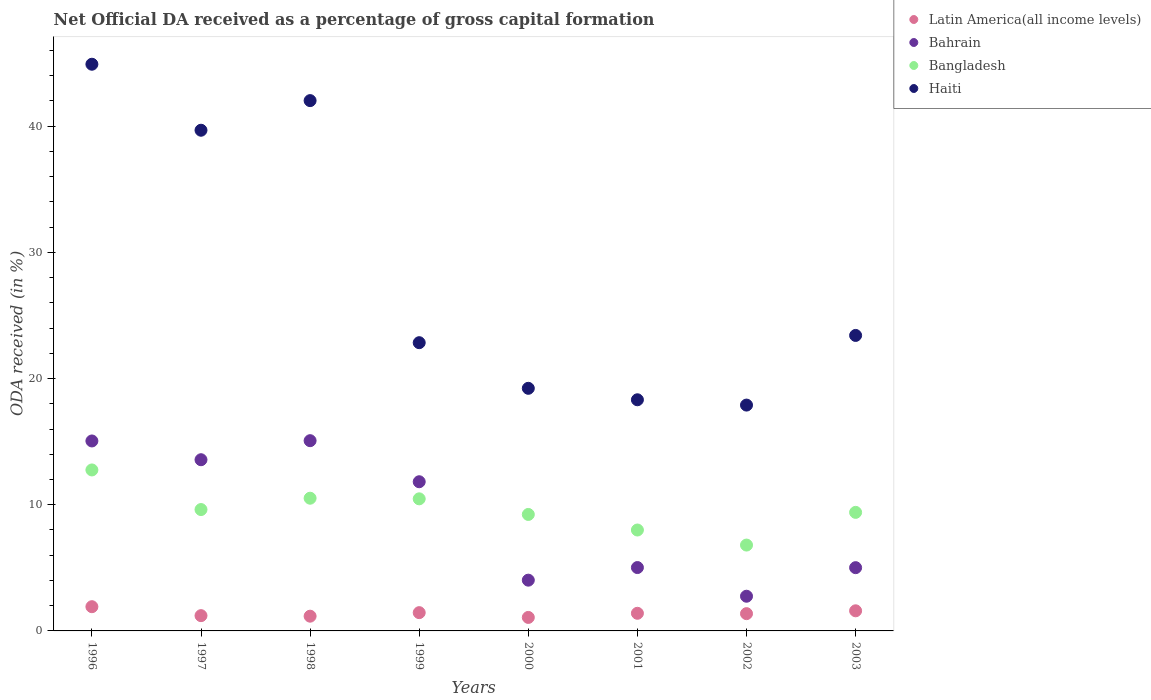How many different coloured dotlines are there?
Offer a terse response. 4. Is the number of dotlines equal to the number of legend labels?
Ensure brevity in your answer.  Yes. What is the net ODA received in Haiti in 2003?
Ensure brevity in your answer.  23.42. Across all years, what is the maximum net ODA received in Latin America(all income levels)?
Give a very brief answer. 1.92. Across all years, what is the minimum net ODA received in Latin America(all income levels)?
Give a very brief answer. 1.07. What is the total net ODA received in Bahrain in the graph?
Make the answer very short. 72.33. What is the difference between the net ODA received in Latin America(all income levels) in 1998 and that in 1999?
Your answer should be compact. -0.28. What is the difference between the net ODA received in Bahrain in 1999 and the net ODA received in Haiti in 1996?
Your answer should be compact. -33.09. What is the average net ODA received in Haiti per year?
Your answer should be very brief. 28.54. In the year 2002, what is the difference between the net ODA received in Bahrain and net ODA received in Latin America(all income levels)?
Offer a terse response. 1.38. What is the ratio of the net ODA received in Bahrain in 1996 to that in 2003?
Give a very brief answer. 3. Is the net ODA received in Bahrain in 2001 less than that in 2002?
Keep it short and to the point. No. What is the difference between the highest and the second highest net ODA received in Bangladesh?
Make the answer very short. 2.24. What is the difference between the highest and the lowest net ODA received in Latin America(all income levels)?
Your answer should be very brief. 0.85. Is the sum of the net ODA received in Latin America(all income levels) in 1996 and 2000 greater than the maximum net ODA received in Haiti across all years?
Keep it short and to the point. No. Is it the case that in every year, the sum of the net ODA received in Haiti and net ODA received in Latin America(all income levels)  is greater than the sum of net ODA received in Bahrain and net ODA received in Bangladesh?
Give a very brief answer. Yes. Does the net ODA received in Bangladesh monotonically increase over the years?
Give a very brief answer. No. Is the net ODA received in Bangladesh strictly less than the net ODA received in Latin America(all income levels) over the years?
Offer a very short reply. No. How many years are there in the graph?
Your answer should be very brief. 8. Are the values on the major ticks of Y-axis written in scientific E-notation?
Provide a short and direct response. No. Where does the legend appear in the graph?
Your response must be concise. Top right. How are the legend labels stacked?
Keep it short and to the point. Vertical. What is the title of the graph?
Your answer should be very brief. Net Official DA received as a percentage of gross capital formation. Does "Uruguay" appear as one of the legend labels in the graph?
Give a very brief answer. No. What is the label or title of the X-axis?
Keep it short and to the point. Years. What is the label or title of the Y-axis?
Your answer should be compact. ODA received (in %). What is the ODA received (in %) of Latin America(all income levels) in 1996?
Keep it short and to the point. 1.92. What is the ODA received (in %) in Bahrain in 1996?
Provide a short and direct response. 15.05. What is the ODA received (in %) of Bangladesh in 1996?
Your answer should be very brief. 12.76. What is the ODA received (in %) of Haiti in 1996?
Your answer should be compact. 44.91. What is the ODA received (in %) in Latin America(all income levels) in 1997?
Offer a very short reply. 1.21. What is the ODA received (in %) of Bahrain in 1997?
Keep it short and to the point. 13.57. What is the ODA received (in %) in Bangladesh in 1997?
Give a very brief answer. 9.62. What is the ODA received (in %) of Haiti in 1997?
Provide a succinct answer. 39.68. What is the ODA received (in %) of Latin America(all income levels) in 1998?
Keep it short and to the point. 1.17. What is the ODA received (in %) of Bahrain in 1998?
Ensure brevity in your answer.  15.08. What is the ODA received (in %) of Bangladesh in 1998?
Keep it short and to the point. 10.52. What is the ODA received (in %) in Haiti in 1998?
Ensure brevity in your answer.  42.03. What is the ODA received (in %) in Latin America(all income levels) in 1999?
Give a very brief answer. 1.45. What is the ODA received (in %) in Bahrain in 1999?
Provide a succinct answer. 11.82. What is the ODA received (in %) of Bangladesh in 1999?
Provide a succinct answer. 10.47. What is the ODA received (in %) in Haiti in 1999?
Your answer should be very brief. 22.84. What is the ODA received (in %) of Latin America(all income levels) in 2000?
Your response must be concise. 1.07. What is the ODA received (in %) of Bahrain in 2000?
Your answer should be compact. 4.02. What is the ODA received (in %) in Bangladesh in 2000?
Your response must be concise. 9.23. What is the ODA received (in %) of Haiti in 2000?
Make the answer very short. 19.23. What is the ODA received (in %) in Latin America(all income levels) in 2001?
Provide a short and direct response. 1.4. What is the ODA received (in %) in Bahrain in 2001?
Your response must be concise. 5.02. What is the ODA received (in %) of Bangladesh in 2001?
Provide a succinct answer. 8. What is the ODA received (in %) in Haiti in 2001?
Offer a terse response. 18.32. What is the ODA received (in %) of Latin America(all income levels) in 2002?
Offer a very short reply. 1.37. What is the ODA received (in %) of Bahrain in 2002?
Offer a very short reply. 2.75. What is the ODA received (in %) in Bangladesh in 2002?
Provide a succinct answer. 6.8. What is the ODA received (in %) of Haiti in 2002?
Offer a very short reply. 17.9. What is the ODA received (in %) in Latin America(all income levels) in 2003?
Make the answer very short. 1.59. What is the ODA received (in %) of Bahrain in 2003?
Your answer should be very brief. 5.01. What is the ODA received (in %) of Bangladesh in 2003?
Make the answer very short. 9.4. What is the ODA received (in %) of Haiti in 2003?
Provide a succinct answer. 23.42. Across all years, what is the maximum ODA received (in %) of Latin America(all income levels)?
Keep it short and to the point. 1.92. Across all years, what is the maximum ODA received (in %) of Bahrain?
Give a very brief answer. 15.08. Across all years, what is the maximum ODA received (in %) in Bangladesh?
Ensure brevity in your answer.  12.76. Across all years, what is the maximum ODA received (in %) in Haiti?
Keep it short and to the point. 44.91. Across all years, what is the minimum ODA received (in %) of Latin America(all income levels)?
Give a very brief answer. 1.07. Across all years, what is the minimum ODA received (in %) in Bahrain?
Give a very brief answer. 2.75. Across all years, what is the minimum ODA received (in %) of Bangladesh?
Your answer should be very brief. 6.8. Across all years, what is the minimum ODA received (in %) of Haiti?
Ensure brevity in your answer.  17.9. What is the total ODA received (in %) of Latin America(all income levels) in the graph?
Give a very brief answer. 11.18. What is the total ODA received (in %) in Bahrain in the graph?
Ensure brevity in your answer.  72.33. What is the total ODA received (in %) of Bangladesh in the graph?
Your response must be concise. 76.79. What is the total ODA received (in %) in Haiti in the graph?
Give a very brief answer. 228.31. What is the difference between the ODA received (in %) in Latin America(all income levels) in 1996 and that in 1997?
Keep it short and to the point. 0.71. What is the difference between the ODA received (in %) of Bahrain in 1996 and that in 1997?
Your answer should be very brief. 1.49. What is the difference between the ODA received (in %) in Bangladesh in 1996 and that in 1997?
Make the answer very short. 3.14. What is the difference between the ODA received (in %) in Haiti in 1996 and that in 1997?
Your response must be concise. 5.23. What is the difference between the ODA received (in %) of Latin America(all income levels) in 1996 and that in 1998?
Make the answer very short. 0.75. What is the difference between the ODA received (in %) in Bahrain in 1996 and that in 1998?
Ensure brevity in your answer.  -0.02. What is the difference between the ODA received (in %) in Bangladesh in 1996 and that in 1998?
Make the answer very short. 2.24. What is the difference between the ODA received (in %) of Haiti in 1996 and that in 1998?
Keep it short and to the point. 2.88. What is the difference between the ODA received (in %) of Latin America(all income levels) in 1996 and that in 1999?
Provide a succinct answer. 0.47. What is the difference between the ODA received (in %) in Bahrain in 1996 and that in 1999?
Ensure brevity in your answer.  3.23. What is the difference between the ODA received (in %) of Bangladesh in 1996 and that in 1999?
Give a very brief answer. 2.29. What is the difference between the ODA received (in %) in Haiti in 1996 and that in 1999?
Provide a succinct answer. 22.07. What is the difference between the ODA received (in %) of Latin America(all income levels) in 1996 and that in 2000?
Give a very brief answer. 0.85. What is the difference between the ODA received (in %) of Bahrain in 1996 and that in 2000?
Ensure brevity in your answer.  11.03. What is the difference between the ODA received (in %) of Bangladesh in 1996 and that in 2000?
Provide a short and direct response. 3.53. What is the difference between the ODA received (in %) in Haiti in 1996 and that in 2000?
Make the answer very short. 25.68. What is the difference between the ODA received (in %) in Latin America(all income levels) in 1996 and that in 2001?
Ensure brevity in your answer.  0.52. What is the difference between the ODA received (in %) of Bahrain in 1996 and that in 2001?
Your answer should be very brief. 10.03. What is the difference between the ODA received (in %) in Bangladesh in 1996 and that in 2001?
Offer a terse response. 4.76. What is the difference between the ODA received (in %) in Haiti in 1996 and that in 2001?
Your answer should be very brief. 26.59. What is the difference between the ODA received (in %) in Latin America(all income levels) in 1996 and that in 2002?
Provide a succinct answer. 0.55. What is the difference between the ODA received (in %) of Bahrain in 1996 and that in 2002?
Keep it short and to the point. 12.3. What is the difference between the ODA received (in %) in Bangladesh in 1996 and that in 2002?
Offer a very short reply. 5.95. What is the difference between the ODA received (in %) of Haiti in 1996 and that in 2002?
Provide a succinct answer. 27.01. What is the difference between the ODA received (in %) in Latin America(all income levels) in 1996 and that in 2003?
Make the answer very short. 0.33. What is the difference between the ODA received (in %) in Bahrain in 1996 and that in 2003?
Offer a terse response. 10.04. What is the difference between the ODA received (in %) in Bangladesh in 1996 and that in 2003?
Make the answer very short. 3.36. What is the difference between the ODA received (in %) in Haiti in 1996 and that in 2003?
Keep it short and to the point. 21.49. What is the difference between the ODA received (in %) in Latin America(all income levels) in 1997 and that in 1998?
Give a very brief answer. 0.04. What is the difference between the ODA received (in %) in Bahrain in 1997 and that in 1998?
Provide a short and direct response. -1.51. What is the difference between the ODA received (in %) of Bangladesh in 1997 and that in 1998?
Provide a succinct answer. -0.9. What is the difference between the ODA received (in %) in Haiti in 1997 and that in 1998?
Offer a very short reply. -2.35. What is the difference between the ODA received (in %) in Latin America(all income levels) in 1997 and that in 1999?
Ensure brevity in your answer.  -0.24. What is the difference between the ODA received (in %) of Bahrain in 1997 and that in 1999?
Provide a succinct answer. 1.74. What is the difference between the ODA received (in %) of Bangladesh in 1997 and that in 1999?
Give a very brief answer. -0.85. What is the difference between the ODA received (in %) of Haiti in 1997 and that in 1999?
Provide a succinct answer. 16.84. What is the difference between the ODA received (in %) of Latin America(all income levels) in 1997 and that in 2000?
Your answer should be compact. 0.14. What is the difference between the ODA received (in %) in Bahrain in 1997 and that in 2000?
Ensure brevity in your answer.  9.54. What is the difference between the ODA received (in %) in Bangladesh in 1997 and that in 2000?
Offer a very short reply. 0.39. What is the difference between the ODA received (in %) of Haiti in 1997 and that in 2000?
Give a very brief answer. 20.45. What is the difference between the ODA received (in %) in Latin America(all income levels) in 1997 and that in 2001?
Give a very brief answer. -0.19. What is the difference between the ODA received (in %) in Bahrain in 1997 and that in 2001?
Your answer should be very brief. 8.55. What is the difference between the ODA received (in %) in Bangladesh in 1997 and that in 2001?
Provide a short and direct response. 1.62. What is the difference between the ODA received (in %) in Haiti in 1997 and that in 2001?
Your answer should be very brief. 21.36. What is the difference between the ODA received (in %) in Latin America(all income levels) in 1997 and that in 2002?
Give a very brief answer. -0.16. What is the difference between the ODA received (in %) of Bahrain in 1997 and that in 2002?
Provide a short and direct response. 10.82. What is the difference between the ODA received (in %) in Bangladesh in 1997 and that in 2002?
Provide a succinct answer. 2.82. What is the difference between the ODA received (in %) of Haiti in 1997 and that in 2002?
Your response must be concise. 21.78. What is the difference between the ODA received (in %) in Latin America(all income levels) in 1997 and that in 2003?
Your answer should be compact. -0.38. What is the difference between the ODA received (in %) in Bahrain in 1997 and that in 2003?
Make the answer very short. 8.55. What is the difference between the ODA received (in %) of Bangladesh in 1997 and that in 2003?
Your answer should be very brief. 0.22. What is the difference between the ODA received (in %) in Haiti in 1997 and that in 2003?
Offer a terse response. 16.26. What is the difference between the ODA received (in %) in Latin America(all income levels) in 1998 and that in 1999?
Ensure brevity in your answer.  -0.28. What is the difference between the ODA received (in %) in Bahrain in 1998 and that in 1999?
Make the answer very short. 3.25. What is the difference between the ODA received (in %) in Bangladesh in 1998 and that in 1999?
Make the answer very short. 0.05. What is the difference between the ODA received (in %) in Haiti in 1998 and that in 1999?
Provide a short and direct response. 19.18. What is the difference between the ODA received (in %) in Latin America(all income levels) in 1998 and that in 2000?
Your response must be concise. 0.1. What is the difference between the ODA received (in %) of Bahrain in 1998 and that in 2000?
Offer a very short reply. 11.05. What is the difference between the ODA received (in %) in Bangladesh in 1998 and that in 2000?
Provide a short and direct response. 1.29. What is the difference between the ODA received (in %) of Haiti in 1998 and that in 2000?
Provide a succinct answer. 22.8. What is the difference between the ODA received (in %) in Latin America(all income levels) in 1998 and that in 2001?
Provide a short and direct response. -0.23. What is the difference between the ODA received (in %) of Bahrain in 1998 and that in 2001?
Make the answer very short. 10.05. What is the difference between the ODA received (in %) of Bangladesh in 1998 and that in 2001?
Provide a succinct answer. 2.52. What is the difference between the ODA received (in %) in Haiti in 1998 and that in 2001?
Your response must be concise. 23.71. What is the difference between the ODA received (in %) of Latin America(all income levels) in 1998 and that in 2002?
Offer a terse response. -0.2. What is the difference between the ODA received (in %) in Bahrain in 1998 and that in 2002?
Make the answer very short. 12.33. What is the difference between the ODA received (in %) of Bangladesh in 1998 and that in 2002?
Offer a terse response. 3.71. What is the difference between the ODA received (in %) in Haiti in 1998 and that in 2002?
Offer a terse response. 24.13. What is the difference between the ODA received (in %) of Latin America(all income levels) in 1998 and that in 2003?
Your response must be concise. -0.43. What is the difference between the ODA received (in %) in Bahrain in 1998 and that in 2003?
Provide a succinct answer. 10.06. What is the difference between the ODA received (in %) of Bangladesh in 1998 and that in 2003?
Your response must be concise. 1.12. What is the difference between the ODA received (in %) in Haiti in 1998 and that in 2003?
Keep it short and to the point. 18.61. What is the difference between the ODA received (in %) of Latin America(all income levels) in 1999 and that in 2000?
Your response must be concise. 0.38. What is the difference between the ODA received (in %) in Bahrain in 1999 and that in 2000?
Your answer should be compact. 7.8. What is the difference between the ODA received (in %) of Bangladesh in 1999 and that in 2000?
Your answer should be compact. 1.24. What is the difference between the ODA received (in %) of Haiti in 1999 and that in 2000?
Provide a succinct answer. 3.62. What is the difference between the ODA received (in %) of Latin America(all income levels) in 1999 and that in 2001?
Offer a very short reply. 0.05. What is the difference between the ODA received (in %) of Bahrain in 1999 and that in 2001?
Provide a succinct answer. 6.8. What is the difference between the ODA received (in %) in Bangladesh in 1999 and that in 2001?
Your response must be concise. 2.47. What is the difference between the ODA received (in %) of Haiti in 1999 and that in 2001?
Your answer should be very brief. 4.52. What is the difference between the ODA received (in %) of Latin America(all income levels) in 1999 and that in 2002?
Your answer should be compact. 0.08. What is the difference between the ODA received (in %) in Bahrain in 1999 and that in 2002?
Ensure brevity in your answer.  9.07. What is the difference between the ODA received (in %) of Bangladesh in 1999 and that in 2002?
Your response must be concise. 3.66. What is the difference between the ODA received (in %) in Haiti in 1999 and that in 2002?
Ensure brevity in your answer.  4.95. What is the difference between the ODA received (in %) of Latin America(all income levels) in 1999 and that in 2003?
Provide a short and direct response. -0.15. What is the difference between the ODA received (in %) in Bahrain in 1999 and that in 2003?
Give a very brief answer. 6.81. What is the difference between the ODA received (in %) in Bangladesh in 1999 and that in 2003?
Offer a terse response. 1.07. What is the difference between the ODA received (in %) of Haiti in 1999 and that in 2003?
Provide a short and direct response. -0.57. What is the difference between the ODA received (in %) of Latin America(all income levels) in 2000 and that in 2001?
Your response must be concise. -0.33. What is the difference between the ODA received (in %) in Bahrain in 2000 and that in 2001?
Provide a short and direct response. -1. What is the difference between the ODA received (in %) in Bangladesh in 2000 and that in 2001?
Ensure brevity in your answer.  1.23. What is the difference between the ODA received (in %) of Haiti in 2000 and that in 2001?
Your response must be concise. 0.91. What is the difference between the ODA received (in %) in Latin America(all income levels) in 2000 and that in 2002?
Keep it short and to the point. -0.3. What is the difference between the ODA received (in %) of Bahrain in 2000 and that in 2002?
Make the answer very short. 1.27. What is the difference between the ODA received (in %) of Bangladesh in 2000 and that in 2002?
Provide a succinct answer. 2.43. What is the difference between the ODA received (in %) in Haiti in 2000 and that in 2002?
Your answer should be compact. 1.33. What is the difference between the ODA received (in %) of Latin America(all income levels) in 2000 and that in 2003?
Your response must be concise. -0.52. What is the difference between the ODA received (in %) of Bahrain in 2000 and that in 2003?
Provide a succinct answer. -0.99. What is the difference between the ODA received (in %) in Bangladesh in 2000 and that in 2003?
Provide a short and direct response. -0.17. What is the difference between the ODA received (in %) in Haiti in 2000 and that in 2003?
Ensure brevity in your answer.  -4.19. What is the difference between the ODA received (in %) in Latin America(all income levels) in 2001 and that in 2002?
Your answer should be very brief. 0.03. What is the difference between the ODA received (in %) of Bahrain in 2001 and that in 2002?
Offer a terse response. 2.27. What is the difference between the ODA received (in %) in Bangladesh in 2001 and that in 2002?
Offer a terse response. 1.19. What is the difference between the ODA received (in %) in Haiti in 2001 and that in 2002?
Provide a short and direct response. 0.42. What is the difference between the ODA received (in %) of Latin America(all income levels) in 2001 and that in 2003?
Offer a very short reply. -0.2. What is the difference between the ODA received (in %) of Bahrain in 2001 and that in 2003?
Provide a short and direct response. 0.01. What is the difference between the ODA received (in %) in Bangladesh in 2001 and that in 2003?
Your answer should be compact. -1.4. What is the difference between the ODA received (in %) in Haiti in 2001 and that in 2003?
Offer a very short reply. -5.1. What is the difference between the ODA received (in %) in Latin America(all income levels) in 2002 and that in 2003?
Give a very brief answer. -0.22. What is the difference between the ODA received (in %) in Bahrain in 2002 and that in 2003?
Keep it short and to the point. -2.26. What is the difference between the ODA received (in %) in Bangladesh in 2002 and that in 2003?
Your answer should be compact. -2.59. What is the difference between the ODA received (in %) in Haiti in 2002 and that in 2003?
Make the answer very short. -5.52. What is the difference between the ODA received (in %) in Latin America(all income levels) in 1996 and the ODA received (in %) in Bahrain in 1997?
Provide a succinct answer. -11.65. What is the difference between the ODA received (in %) in Latin America(all income levels) in 1996 and the ODA received (in %) in Bangladesh in 1997?
Give a very brief answer. -7.7. What is the difference between the ODA received (in %) in Latin America(all income levels) in 1996 and the ODA received (in %) in Haiti in 1997?
Provide a succinct answer. -37.76. What is the difference between the ODA received (in %) in Bahrain in 1996 and the ODA received (in %) in Bangladesh in 1997?
Make the answer very short. 5.44. What is the difference between the ODA received (in %) of Bahrain in 1996 and the ODA received (in %) of Haiti in 1997?
Provide a short and direct response. -24.62. What is the difference between the ODA received (in %) in Bangladesh in 1996 and the ODA received (in %) in Haiti in 1997?
Provide a short and direct response. -26.92. What is the difference between the ODA received (in %) of Latin America(all income levels) in 1996 and the ODA received (in %) of Bahrain in 1998?
Give a very brief answer. -13.16. What is the difference between the ODA received (in %) in Latin America(all income levels) in 1996 and the ODA received (in %) in Bangladesh in 1998?
Give a very brief answer. -8.6. What is the difference between the ODA received (in %) in Latin America(all income levels) in 1996 and the ODA received (in %) in Haiti in 1998?
Offer a very short reply. -40.11. What is the difference between the ODA received (in %) of Bahrain in 1996 and the ODA received (in %) of Bangladesh in 1998?
Your response must be concise. 4.54. What is the difference between the ODA received (in %) of Bahrain in 1996 and the ODA received (in %) of Haiti in 1998?
Offer a very short reply. -26.97. What is the difference between the ODA received (in %) in Bangladesh in 1996 and the ODA received (in %) in Haiti in 1998?
Offer a very short reply. -29.27. What is the difference between the ODA received (in %) in Latin America(all income levels) in 1996 and the ODA received (in %) in Bahrain in 1999?
Keep it short and to the point. -9.9. What is the difference between the ODA received (in %) in Latin America(all income levels) in 1996 and the ODA received (in %) in Bangladesh in 1999?
Provide a short and direct response. -8.55. What is the difference between the ODA received (in %) of Latin America(all income levels) in 1996 and the ODA received (in %) of Haiti in 1999?
Give a very brief answer. -20.92. What is the difference between the ODA received (in %) of Bahrain in 1996 and the ODA received (in %) of Bangladesh in 1999?
Make the answer very short. 4.59. What is the difference between the ODA received (in %) of Bahrain in 1996 and the ODA received (in %) of Haiti in 1999?
Provide a succinct answer. -7.79. What is the difference between the ODA received (in %) of Bangladesh in 1996 and the ODA received (in %) of Haiti in 1999?
Keep it short and to the point. -10.09. What is the difference between the ODA received (in %) in Latin America(all income levels) in 1996 and the ODA received (in %) in Bahrain in 2000?
Your answer should be very brief. -2.1. What is the difference between the ODA received (in %) in Latin America(all income levels) in 1996 and the ODA received (in %) in Bangladesh in 2000?
Provide a succinct answer. -7.31. What is the difference between the ODA received (in %) in Latin America(all income levels) in 1996 and the ODA received (in %) in Haiti in 2000?
Ensure brevity in your answer.  -17.31. What is the difference between the ODA received (in %) in Bahrain in 1996 and the ODA received (in %) in Bangladesh in 2000?
Your answer should be very brief. 5.82. What is the difference between the ODA received (in %) of Bahrain in 1996 and the ODA received (in %) of Haiti in 2000?
Ensure brevity in your answer.  -4.17. What is the difference between the ODA received (in %) of Bangladesh in 1996 and the ODA received (in %) of Haiti in 2000?
Ensure brevity in your answer.  -6.47. What is the difference between the ODA received (in %) in Latin America(all income levels) in 1996 and the ODA received (in %) in Bahrain in 2001?
Your response must be concise. -3.1. What is the difference between the ODA received (in %) of Latin America(all income levels) in 1996 and the ODA received (in %) of Bangladesh in 2001?
Your answer should be very brief. -6.08. What is the difference between the ODA received (in %) in Latin America(all income levels) in 1996 and the ODA received (in %) in Haiti in 2001?
Make the answer very short. -16.4. What is the difference between the ODA received (in %) in Bahrain in 1996 and the ODA received (in %) in Bangladesh in 2001?
Provide a succinct answer. 7.06. What is the difference between the ODA received (in %) in Bahrain in 1996 and the ODA received (in %) in Haiti in 2001?
Offer a very short reply. -3.26. What is the difference between the ODA received (in %) in Bangladesh in 1996 and the ODA received (in %) in Haiti in 2001?
Provide a short and direct response. -5.56. What is the difference between the ODA received (in %) in Latin America(all income levels) in 1996 and the ODA received (in %) in Bahrain in 2002?
Your response must be concise. -0.83. What is the difference between the ODA received (in %) in Latin America(all income levels) in 1996 and the ODA received (in %) in Bangladesh in 2002?
Offer a very short reply. -4.88. What is the difference between the ODA received (in %) in Latin America(all income levels) in 1996 and the ODA received (in %) in Haiti in 2002?
Provide a succinct answer. -15.98. What is the difference between the ODA received (in %) in Bahrain in 1996 and the ODA received (in %) in Bangladesh in 2002?
Your answer should be very brief. 8.25. What is the difference between the ODA received (in %) of Bahrain in 1996 and the ODA received (in %) of Haiti in 2002?
Your answer should be compact. -2.84. What is the difference between the ODA received (in %) of Bangladesh in 1996 and the ODA received (in %) of Haiti in 2002?
Your answer should be compact. -5.14. What is the difference between the ODA received (in %) in Latin America(all income levels) in 1996 and the ODA received (in %) in Bahrain in 2003?
Provide a succinct answer. -3.09. What is the difference between the ODA received (in %) in Latin America(all income levels) in 1996 and the ODA received (in %) in Bangladesh in 2003?
Your answer should be compact. -7.48. What is the difference between the ODA received (in %) of Latin America(all income levels) in 1996 and the ODA received (in %) of Haiti in 2003?
Provide a succinct answer. -21.5. What is the difference between the ODA received (in %) in Bahrain in 1996 and the ODA received (in %) in Bangladesh in 2003?
Your answer should be compact. 5.66. What is the difference between the ODA received (in %) of Bahrain in 1996 and the ODA received (in %) of Haiti in 2003?
Offer a terse response. -8.36. What is the difference between the ODA received (in %) of Bangladesh in 1996 and the ODA received (in %) of Haiti in 2003?
Provide a short and direct response. -10.66. What is the difference between the ODA received (in %) of Latin America(all income levels) in 1997 and the ODA received (in %) of Bahrain in 1998?
Provide a succinct answer. -13.87. What is the difference between the ODA received (in %) of Latin America(all income levels) in 1997 and the ODA received (in %) of Bangladesh in 1998?
Your answer should be very brief. -9.31. What is the difference between the ODA received (in %) of Latin America(all income levels) in 1997 and the ODA received (in %) of Haiti in 1998?
Offer a terse response. -40.82. What is the difference between the ODA received (in %) of Bahrain in 1997 and the ODA received (in %) of Bangladesh in 1998?
Give a very brief answer. 3.05. What is the difference between the ODA received (in %) of Bahrain in 1997 and the ODA received (in %) of Haiti in 1998?
Your answer should be compact. -28.46. What is the difference between the ODA received (in %) of Bangladesh in 1997 and the ODA received (in %) of Haiti in 1998?
Your answer should be compact. -32.41. What is the difference between the ODA received (in %) of Latin America(all income levels) in 1997 and the ODA received (in %) of Bahrain in 1999?
Provide a short and direct response. -10.61. What is the difference between the ODA received (in %) of Latin America(all income levels) in 1997 and the ODA received (in %) of Bangladesh in 1999?
Keep it short and to the point. -9.26. What is the difference between the ODA received (in %) of Latin America(all income levels) in 1997 and the ODA received (in %) of Haiti in 1999?
Ensure brevity in your answer.  -21.63. What is the difference between the ODA received (in %) in Bahrain in 1997 and the ODA received (in %) in Bangladesh in 1999?
Your answer should be very brief. 3.1. What is the difference between the ODA received (in %) in Bahrain in 1997 and the ODA received (in %) in Haiti in 1999?
Your answer should be very brief. -9.28. What is the difference between the ODA received (in %) in Bangladesh in 1997 and the ODA received (in %) in Haiti in 1999?
Give a very brief answer. -13.22. What is the difference between the ODA received (in %) in Latin America(all income levels) in 1997 and the ODA received (in %) in Bahrain in 2000?
Make the answer very short. -2.81. What is the difference between the ODA received (in %) in Latin America(all income levels) in 1997 and the ODA received (in %) in Bangladesh in 2000?
Your answer should be compact. -8.02. What is the difference between the ODA received (in %) of Latin America(all income levels) in 1997 and the ODA received (in %) of Haiti in 2000?
Give a very brief answer. -18.02. What is the difference between the ODA received (in %) in Bahrain in 1997 and the ODA received (in %) in Bangladesh in 2000?
Offer a very short reply. 4.34. What is the difference between the ODA received (in %) in Bahrain in 1997 and the ODA received (in %) in Haiti in 2000?
Provide a succinct answer. -5.66. What is the difference between the ODA received (in %) of Bangladesh in 1997 and the ODA received (in %) of Haiti in 2000?
Provide a short and direct response. -9.61. What is the difference between the ODA received (in %) of Latin America(all income levels) in 1997 and the ODA received (in %) of Bahrain in 2001?
Your answer should be compact. -3.81. What is the difference between the ODA received (in %) in Latin America(all income levels) in 1997 and the ODA received (in %) in Bangladesh in 2001?
Ensure brevity in your answer.  -6.79. What is the difference between the ODA received (in %) of Latin America(all income levels) in 1997 and the ODA received (in %) of Haiti in 2001?
Make the answer very short. -17.11. What is the difference between the ODA received (in %) of Bahrain in 1997 and the ODA received (in %) of Bangladesh in 2001?
Offer a very short reply. 5.57. What is the difference between the ODA received (in %) in Bahrain in 1997 and the ODA received (in %) in Haiti in 2001?
Offer a very short reply. -4.75. What is the difference between the ODA received (in %) in Bangladesh in 1997 and the ODA received (in %) in Haiti in 2001?
Your answer should be compact. -8.7. What is the difference between the ODA received (in %) in Latin America(all income levels) in 1997 and the ODA received (in %) in Bahrain in 2002?
Give a very brief answer. -1.54. What is the difference between the ODA received (in %) of Latin America(all income levels) in 1997 and the ODA received (in %) of Bangladesh in 2002?
Make the answer very short. -5.59. What is the difference between the ODA received (in %) in Latin America(all income levels) in 1997 and the ODA received (in %) in Haiti in 2002?
Your answer should be very brief. -16.69. What is the difference between the ODA received (in %) in Bahrain in 1997 and the ODA received (in %) in Bangladesh in 2002?
Keep it short and to the point. 6.76. What is the difference between the ODA received (in %) of Bahrain in 1997 and the ODA received (in %) of Haiti in 2002?
Make the answer very short. -4.33. What is the difference between the ODA received (in %) of Bangladesh in 1997 and the ODA received (in %) of Haiti in 2002?
Your response must be concise. -8.28. What is the difference between the ODA received (in %) of Latin America(all income levels) in 1997 and the ODA received (in %) of Bahrain in 2003?
Give a very brief answer. -3.8. What is the difference between the ODA received (in %) in Latin America(all income levels) in 1997 and the ODA received (in %) in Bangladesh in 2003?
Ensure brevity in your answer.  -8.19. What is the difference between the ODA received (in %) of Latin America(all income levels) in 1997 and the ODA received (in %) of Haiti in 2003?
Offer a terse response. -22.21. What is the difference between the ODA received (in %) in Bahrain in 1997 and the ODA received (in %) in Bangladesh in 2003?
Your answer should be very brief. 4.17. What is the difference between the ODA received (in %) in Bahrain in 1997 and the ODA received (in %) in Haiti in 2003?
Provide a short and direct response. -9.85. What is the difference between the ODA received (in %) of Bangladesh in 1997 and the ODA received (in %) of Haiti in 2003?
Your answer should be very brief. -13.8. What is the difference between the ODA received (in %) of Latin America(all income levels) in 1998 and the ODA received (in %) of Bahrain in 1999?
Your response must be concise. -10.65. What is the difference between the ODA received (in %) of Latin America(all income levels) in 1998 and the ODA received (in %) of Bangladesh in 1999?
Your answer should be compact. -9.3. What is the difference between the ODA received (in %) in Latin America(all income levels) in 1998 and the ODA received (in %) in Haiti in 1999?
Provide a succinct answer. -21.67. What is the difference between the ODA received (in %) in Bahrain in 1998 and the ODA received (in %) in Bangladesh in 1999?
Give a very brief answer. 4.61. What is the difference between the ODA received (in %) of Bahrain in 1998 and the ODA received (in %) of Haiti in 1999?
Offer a very short reply. -7.77. What is the difference between the ODA received (in %) of Bangladesh in 1998 and the ODA received (in %) of Haiti in 1999?
Provide a short and direct response. -12.33. What is the difference between the ODA received (in %) in Latin America(all income levels) in 1998 and the ODA received (in %) in Bahrain in 2000?
Provide a short and direct response. -2.85. What is the difference between the ODA received (in %) in Latin America(all income levels) in 1998 and the ODA received (in %) in Bangladesh in 2000?
Provide a short and direct response. -8.06. What is the difference between the ODA received (in %) in Latin America(all income levels) in 1998 and the ODA received (in %) in Haiti in 2000?
Keep it short and to the point. -18.06. What is the difference between the ODA received (in %) in Bahrain in 1998 and the ODA received (in %) in Bangladesh in 2000?
Offer a very short reply. 5.85. What is the difference between the ODA received (in %) of Bahrain in 1998 and the ODA received (in %) of Haiti in 2000?
Provide a succinct answer. -4.15. What is the difference between the ODA received (in %) in Bangladesh in 1998 and the ODA received (in %) in Haiti in 2000?
Offer a terse response. -8.71. What is the difference between the ODA received (in %) in Latin America(all income levels) in 1998 and the ODA received (in %) in Bahrain in 2001?
Provide a succinct answer. -3.85. What is the difference between the ODA received (in %) in Latin America(all income levels) in 1998 and the ODA received (in %) in Bangladesh in 2001?
Offer a very short reply. -6.83. What is the difference between the ODA received (in %) of Latin America(all income levels) in 1998 and the ODA received (in %) of Haiti in 2001?
Offer a terse response. -17.15. What is the difference between the ODA received (in %) in Bahrain in 1998 and the ODA received (in %) in Bangladesh in 2001?
Offer a very short reply. 7.08. What is the difference between the ODA received (in %) of Bahrain in 1998 and the ODA received (in %) of Haiti in 2001?
Ensure brevity in your answer.  -3.24. What is the difference between the ODA received (in %) of Bangladesh in 1998 and the ODA received (in %) of Haiti in 2001?
Keep it short and to the point. -7.8. What is the difference between the ODA received (in %) of Latin America(all income levels) in 1998 and the ODA received (in %) of Bahrain in 2002?
Provide a short and direct response. -1.58. What is the difference between the ODA received (in %) of Latin America(all income levels) in 1998 and the ODA received (in %) of Bangladesh in 2002?
Give a very brief answer. -5.64. What is the difference between the ODA received (in %) of Latin America(all income levels) in 1998 and the ODA received (in %) of Haiti in 2002?
Offer a very short reply. -16.73. What is the difference between the ODA received (in %) in Bahrain in 1998 and the ODA received (in %) in Bangladesh in 2002?
Provide a short and direct response. 8.27. What is the difference between the ODA received (in %) in Bahrain in 1998 and the ODA received (in %) in Haiti in 2002?
Your answer should be very brief. -2.82. What is the difference between the ODA received (in %) in Bangladesh in 1998 and the ODA received (in %) in Haiti in 2002?
Provide a short and direct response. -7.38. What is the difference between the ODA received (in %) in Latin America(all income levels) in 1998 and the ODA received (in %) in Bahrain in 2003?
Offer a very short reply. -3.84. What is the difference between the ODA received (in %) of Latin America(all income levels) in 1998 and the ODA received (in %) of Bangladesh in 2003?
Your answer should be compact. -8.23. What is the difference between the ODA received (in %) in Latin America(all income levels) in 1998 and the ODA received (in %) in Haiti in 2003?
Your response must be concise. -22.25. What is the difference between the ODA received (in %) of Bahrain in 1998 and the ODA received (in %) of Bangladesh in 2003?
Give a very brief answer. 5.68. What is the difference between the ODA received (in %) of Bahrain in 1998 and the ODA received (in %) of Haiti in 2003?
Your answer should be compact. -8.34. What is the difference between the ODA received (in %) of Bangladesh in 1998 and the ODA received (in %) of Haiti in 2003?
Make the answer very short. -12.9. What is the difference between the ODA received (in %) of Latin America(all income levels) in 1999 and the ODA received (in %) of Bahrain in 2000?
Provide a succinct answer. -2.57. What is the difference between the ODA received (in %) of Latin America(all income levels) in 1999 and the ODA received (in %) of Bangladesh in 2000?
Keep it short and to the point. -7.78. What is the difference between the ODA received (in %) in Latin America(all income levels) in 1999 and the ODA received (in %) in Haiti in 2000?
Offer a very short reply. -17.78. What is the difference between the ODA received (in %) in Bahrain in 1999 and the ODA received (in %) in Bangladesh in 2000?
Your response must be concise. 2.59. What is the difference between the ODA received (in %) in Bahrain in 1999 and the ODA received (in %) in Haiti in 2000?
Your answer should be compact. -7.4. What is the difference between the ODA received (in %) of Bangladesh in 1999 and the ODA received (in %) of Haiti in 2000?
Offer a terse response. -8.76. What is the difference between the ODA received (in %) in Latin America(all income levels) in 1999 and the ODA received (in %) in Bahrain in 2001?
Your response must be concise. -3.57. What is the difference between the ODA received (in %) of Latin America(all income levels) in 1999 and the ODA received (in %) of Bangladesh in 2001?
Make the answer very short. -6.55. What is the difference between the ODA received (in %) of Latin America(all income levels) in 1999 and the ODA received (in %) of Haiti in 2001?
Make the answer very short. -16.87. What is the difference between the ODA received (in %) in Bahrain in 1999 and the ODA received (in %) in Bangladesh in 2001?
Keep it short and to the point. 3.83. What is the difference between the ODA received (in %) in Bahrain in 1999 and the ODA received (in %) in Haiti in 2001?
Provide a succinct answer. -6.5. What is the difference between the ODA received (in %) in Bangladesh in 1999 and the ODA received (in %) in Haiti in 2001?
Your answer should be very brief. -7.85. What is the difference between the ODA received (in %) of Latin America(all income levels) in 1999 and the ODA received (in %) of Bahrain in 2002?
Offer a terse response. -1.3. What is the difference between the ODA received (in %) in Latin America(all income levels) in 1999 and the ODA received (in %) in Bangladesh in 2002?
Offer a terse response. -5.35. What is the difference between the ODA received (in %) in Latin America(all income levels) in 1999 and the ODA received (in %) in Haiti in 2002?
Offer a very short reply. -16.45. What is the difference between the ODA received (in %) in Bahrain in 1999 and the ODA received (in %) in Bangladesh in 2002?
Your answer should be compact. 5.02. What is the difference between the ODA received (in %) in Bahrain in 1999 and the ODA received (in %) in Haiti in 2002?
Ensure brevity in your answer.  -6.07. What is the difference between the ODA received (in %) of Bangladesh in 1999 and the ODA received (in %) of Haiti in 2002?
Offer a terse response. -7.43. What is the difference between the ODA received (in %) of Latin America(all income levels) in 1999 and the ODA received (in %) of Bahrain in 2003?
Ensure brevity in your answer.  -3.56. What is the difference between the ODA received (in %) in Latin America(all income levels) in 1999 and the ODA received (in %) in Bangladesh in 2003?
Give a very brief answer. -7.95. What is the difference between the ODA received (in %) of Latin America(all income levels) in 1999 and the ODA received (in %) of Haiti in 2003?
Provide a succinct answer. -21.97. What is the difference between the ODA received (in %) of Bahrain in 1999 and the ODA received (in %) of Bangladesh in 2003?
Ensure brevity in your answer.  2.43. What is the difference between the ODA received (in %) of Bahrain in 1999 and the ODA received (in %) of Haiti in 2003?
Offer a terse response. -11.59. What is the difference between the ODA received (in %) in Bangladesh in 1999 and the ODA received (in %) in Haiti in 2003?
Your answer should be very brief. -12.95. What is the difference between the ODA received (in %) of Latin America(all income levels) in 2000 and the ODA received (in %) of Bahrain in 2001?
Your answer should be compact. -3.95. What is the difference between the ODA received (in %) of Latin America(all income levels) in 2000 and the ODA received (in %) of Bangladesh in 2001?
Your answer should be very brief. -6.93. What is the difference between the ODA received (in %) of Latin America(all income levels) in 2000 and the ODA received (in %) of Haiti in 2001?
Keep it short and to the point. -17.25. What is the difference between the ODA received (in %) in Bahrain in 2000 and the ODA received (in %) in Bangladesh in 2001?
Offer a terse response. -3.97. What is the difference between the ODA received (in %) of Bahrain in 2000 and the ODA received (in %) of Haiti in 2001?
Ensure brevity in your answer.  -14.29. What is the difference between the ODA received (in %) in Bangladesh in 2000 and the ODA received (in %) in Haiti in 2001?
Keep it short and to the point. -9.09. What is the difference between the ODA received (in %) in Latin America(all income levels) in 2000 and the ODA received (in %) in Bahrain in 2002?
Provide a succinct answer. -1.68. What is the difference between the ODA received (in %) of Latin America(all income levels) in 2000 and the ODA received (in %) of Bangladesh in 2002?
Give a very brief answer. -5.73. What is the difference between the ODA received (in %) in Latin America(all income levels) in 2000 and the ODA received (in %) in Haiti in 2002?
Keep it short and to the point. -16.83. What is the difference between the ODA received (in %) in Bahrain in 2000 and the ODA received (in %) in Bangladesh in 2002?
Your answer should be compact. -2.78. What is the difference between the ODA received (in %) of Bahrain in 2000 and the ODA received (in %) of Haiti in 2002?
Ensure brevity in your answer.  -13.87. What is the difference between the ODA received (in %) in Bangladesh in 2000 and the ODA received (in %) in Haiti in 2002?
Your answer should be very brief. -8.67. What is the difference between the ODA received (in %) in Latin America(all income levels) in 2000 and the ODA received (in %) in Bahrain in 2003?
Provide a short and direct response. -3.94. What is the difference between the ODA received (in %) of Latin America(all income levels) in 2000 and the ODA received (in %) of Bangladesh in 2003?
Keep it short and to the point. -8.33. What is the difference between the ODA received (in %) in Latin America(all income levels) in 2000 and the ODA received (in %) in Haiti in 2003?
Give a very brief answer. -22.35. What is the difference between the ODA received (in %) of Bahrain in 2000 and the ODA received (in %) of Bangladesh in 2003?
Provide a short and direct response. -5.37. What is the difference between the ODA received (in %) in Bahrain in 2000 and the ODA received (in %) in Haiti in 2003?
Ensure brevity in your answer.  -19.39. What is the difference between the ODA received (in %) of Bangladesh in 2000 and the ODA received (in %) of Haiti in 2003?
Give a very brief answer. -14.19. What is the difference between the ODA received (in %) of Latin America(all income levels) in 2001 and the ODA received (in %) of Bahrain in 2002?
Keep it short and to the point. -1.35. What is the difference between the ODA received (in %) in Latin America(all income levels) in 2001 and the ODA received (in %) in Bangladesh in 2002?
Ensure brevity in your answer.  -5.41. What is the difference between the ODA received (in %) of Latin America(all income levels) in 2001 and the ODA received (in %) of Haiti in 2002?
Your response must be concise. -16.5. What is the difference between the ODA received (in %) of Bahrain in 2001 and the ODA received (in %) of Bangladesh in 2002?
Offer a terse response. -1.78. What is the difference between the ODA received (in %) of Bahrain in 2001 and the ODA received (in %) of Haiti in 2002?
Make the answer very short. -12.88. What is the difference between the ODA received (in %) of Bangladesh in 2001 and the ODA received (in %) of Haiti in 2002?
Provide a succinct answer. -9.9. What is the difference between the ODA received (in %) of Latin America(all income levels) in 2001 and the ODA received (in %) of Bahrain in 2003?
Offer a terse response. -3.62. What is the difference between the ODA received (in %) of Latin America(all income levels) in 2001 and the ODA received (in %) of Bangladesh in 2003?
Offer a very short reply. -8. What is the difference between the ODA received (in %) of Latin America(all income levels) in 2001 and the ODA received (in %) of Haiti in 2003?
Your response must be concise. -22.02. What is the difference between the ODA received (in %) in Bahrain in 2001 and the ODA received (in %) in Bangladesh in 2003?
Offer a very short reply. -4.37. What is the difference between the ODA received (in %) of Bahrain in 2001 and the ODA received (in %) of Haiti in 2003?
Offer a terse response. -18.4. What is the difference between the ODA received (in %) of Bangladesh in 2001 and the ODA received (in %) of Haiti in 2003?
Your answer should be very brief. -15.42. What is the difference between the ODA received (in %) in Latin America(all income levels) in 2002 and the ODA received (in %) in Bahrain in 2003?
Make the answer very short. -3.64. What is the difference between the ODA received (in %) in Latin America(all income levels) in 2002 and the ODA received (in %) in Bangladesh in 2003?
Provide a short and direct response. -8.03. What is the difference between the ODA received (in %) of Latin America(all income levels) in 2002 and the ODA received (in %) of Haiti in 2003?
Give a very brief answer. -22.05. What is the difference between the ODA received (in %) in Bahrain in 2002 and the ODA received (in %) in Bangladesh in 2003?
Your response must be concise. -6.65. What is the difference between the ODA received (in %) of Bahrain in 2002 and the ODA received (in %) of Haiti in 2003?
Make the answer very short. -20.67. What is the difference between the ODA received (in %) of Bangladesh in 2002 and the ODA received (in %) of Haiti in 2003?
Offer a very short reply. -16.61. What is the average ODA received (in %) in Latin America(all income levels) per year?
Offer a terse response. 1.4. What is the average ODA received (in %) in Bahrain per year?
Provide a succinct answer. 9.04. What is the average ODA received (in %) of Bangladesh per year?
Give a very brief answer. 9.6. What is the average ODA received (in %) of Haiti per year?
Offer a very short reply. 28.54. In the year 1996, what is the difference between the ODA received (in %) of Latin America(all income levels) and ODA received (in %) of Bahrain?
Your answer should be very brief. -13.13. In the year 1996, what is the difference between the ODA received (in %) of Latin America(all income levels) and ODA received (in %) of Bangladesh?
Give a very brief answer. -10.84. In the year 1996, what is the difference between the ODA received (in %) of Latin America(all income levels) and ODA received (in %) of Haiti?
Offer a terse response. -42.99. In the year 1996, what is the difference between the ODA received (in %) in Bahrain and ODA received (in %) in Bangladesh?
Your answer should be compact. 2.3. In the year 1996, what is the difference between the ODA received (in %) of Bahrain and ODA received (in %) of Haiti?
Keep it short and to the point. -29.86. In the year 1996, what is the difference between the ODA received (in %) in Bangladesh and ODA received (in %) in Haiti?
Give a very brief answer. -32.15. In the year 1997, what is the difference between the ODA received (in %) in Latin America(all income levels) and ODA received (in %) in Bahrain?
Your response must be concise. -12.36. In the year 1997, what is the difference between the ODA received (in %) of Latin America(all income levels) and ODA received (in %) of Bangladesh?
Keep it short and to the point. -8.41. In the year 1997, what is the difference between the ODA received (in %) of Latin America(all income levels) and ODA received (in %) of Haiti?
Your response must be concise. -38.47. In the year 1997, what is the difference between the ODA received (in %) in Bahrain and ODA received (in %) in Bangladesh?
Your answer should be very brief. 3.95. In the year 1997, what is the difference between the ODA received (in %) in Bahrain and ODA received (in %) in Haiti?
Make the answer very short. -26.11. In the year 1997, what is the difference between the ODA received (in %) in Bangladesh and ODA received (in %) in Haiti?
Your response must be concise. -30.06. In the year 1998, what is the difference between the ODA received (in %) in Latin America(all income levels) and ODA received (in %) in Bahrain?
Offer a very short reply. -13.91. In the year 1998, what is the difference between the ODA received (in %) of Latin America(all income levels) and ODA received (in %) of Bangladesh?
Offer a very short reply. -9.35. In the year 1998, what is the difference between the ODA received (in %) of Latin America(all income levels) and ODA received (in %) of Haiti?
Offer a very short reply. -40.86. In the year 1998, what is the difference between the ODA received (in %) in Bahrain and ODA received (in %) in Bangladesh?
Ensure brevity in your answer.  4.56. In the year 1998, what is the difference between the ODA received (in %) of Bahrain and ODA received (in %) of Haiti?
Provide a succinct answer. -26.95. In the year 1998, what is the difference between the ODA received (in %) of Bangladesh and ODA received (in %) of Haiti?
Provide a short and direct response. -31.51. In the year 1999, what is the difference between the ODA received (in %) in Latin America(all income levels) and ODA received (in %) in Bahrain?
Offer a very short reply. -10.37. In the year 1999, what is the difference between the ODA received (in %) of Latin America(all income levels) and ODA received (in %) of Bangladesh?
Your answer should be very brief. -9.02. In the year 1999, what is the difference between the ODA received (in %) in Latin America(all income levels) and ODA received (in %) in Haiti?
Ensure brevity in your answer.  -21.39. In the year 1999, what is the difference between the ODA received (in %) of Bahrain and ODA received (in %) of Bangladesh?
Your response must be concise. 1.35. In the year 1999, what is the difference between the ODA received (in %) of Bahrain and ODA received (in %) of Haiti?
Your answer should be compact. -11.02. In the year 1999, what is the difference between the ODA received (in %) in Bangladesh and ODA received (in %) in Haiti?
Provide a short and direct response. -12.37. In the year 2000, what is the difference between the ODA received (in %) in Latin America(all income levels) and ODA received (in %) in Bahrain?
Provide a short and direct response. -2.95. In the year 2000, what is the difference between the ODA received (in %) of Latin America(all income levels) and ODA received (in %) of Bangladesh?
Make the answer very short. -8.16. In the year 2000, what is the difference between the ODA received (in %) of Latin America(all income levels) and ODA received (in %) of Haiti?
Give a very brief answer. -18.16. In the year 2000, what is the difference between the ODA received (in %) of Bahrain and ODA received (in %) of Bangladesh?
Offer a terse response. -5.21. In the year 2000, what is the difference between the ODA received (in %) in Bahrain and ODA received (in %) in Haiti?
Ensure brevity in your answer.  -15.2. In the year 2000, what is the difference between the ODA received (in %) of Bangladesh and ODA received (in %) of Haiti?
Provide a short and direct response. -10. In the year 2001, what is the difference between the ODA received (in %) of Latin America(all income levels) and ODA received (in %) of Bahrain?
Offer a terse response. -3.62. In the year 2001, what is the difference between the ODA received (in %) of Latin America(all income levels) and ODA received (in %) of Bangladesh?
Provide a short and direct response. -6.6. In the year 2001, what is the difference between the ODA received (in %) of Latin America(all income levels) and ODA received (in %) of Haiti?
Provide a succinct answer. -16.92. In the year 2001, what is the difference between the ODA received (in %) in Bahrain and ODA received (in %) in Bangladesh?
Provide a succinct answer. -2.98. In the year 2001, what is the difference between the ODA received (in %) in Bahrain and ODA received (in %) in Haiti?
Your response must be concise. -13.3. In the year 2001, what is the difference between the ODA received (in %) in Bangladesh and ODA received (in %) in Haiti?
Your answer should be very brief. -10.32. In the year 2002, what is the difference between the ODA received (in %) in Latin America(all income levels) and ODA received (in %) in Bahrain?
Keep it short and to the point. -1.38. In the year 2002, what is the difference between the ODA received (in %) in Latin America(all income levels) and ODA received (in %) in Bangladesh?
Your response must be concise. -5.43. In the year 2002, what is the difference between the ODA received (in %) of Latin America(all income levels) and ODA received (in %) of Haiti?
Ensure brevity in your answer.  -16.53. In the year 2002, what is the difference between the ODA received (in %) in Bahrain and ODA received (in %) in Bangladesh?
Ensure brevity in your answer.  -4.05. In the year 2002, what is the difference between the ODA received (in %) in Bahrain and ODA received (in %) in Haiti?
Provide a succinct answer. -15.15. In the year 2002, what is the difference between the ODA received (in %) of Bangladesh and ODA received (in %) of Haiti?
Offer a very short reply. -11.09. In the year 2003, what is the difference between the ODA received (in %) in Latin America(all income levels) and ODA received (in %) in Bahrain?
Provide a short and direct response. -3.42. In the year 2003, what is the difference between the ODA received (in %) of Latin America(all income levels) and ODA received (in %) of Bangladesh?
Your response must be concise. -7.8. In the year 2003, what is the difference between the ODA received (in %) in Latin America(all income levels) and ODA received (in %) in Haiti?
Provide a short and direct response. -21.82. In the year 2003, what is the difference between the ODA received (in %) of Bahrain and ODA received (in %) of Bangladesh?
Ensure brevity in your answer.  -4.38. In the year 2003, what is the difference between the ODA received (in %) of Bahrain and ODA received (in %) of Haiti?
Give a very brief answer. -18.4. In the year 2003, what is the difference between the ODA received (in %) of Bangladesh and ODA received (in %) of Haiti?
Make the answer very short. -14.02. What is the ratio of the ODA received (in %) of Latin America(all income levels) in 1996 to that in 1997?
Make the answer very short. 1.59. What is the ratio of the ODA received (in %) of Bahrain in 1996 to that in 1997?
Your response must be concise. 1.11. What is the ratio of the ODA received (in %) in Bangladesh in 1996 to that in 1997?
Ensure brevity in your answer.  1.33. What is the ratio of the ODA received (in %) of Haiti in 1996 to that in 1997?
Keep it short and to the point. 1.13. What is the ratio of the ODA received (in %) in Latin America(all income levels) in 1996 to that in 1998?
Your answer should be very brief. 1.64. What is the ratio of the ODA received (in %) of Bangladesh in 1996 to that in 1998?
Your answer should be very brief. 1.21. What is the ratio of the ODA received (in %) of Haiti in 1996 to that in 1998?
Offer a very short reply. 1.07. What is the ratio of the ODA received (in %) in Latin America(all income levels) in 1996 to that in 1999?
Provide a succinct answer. 1.33. What is the ratio of the ODA received (in %) of Bahrain in 1996 to that in 1999?
Your answer should be very brief. 1.27. What is the ratio of the ODA received (in %) of Bangladesh in 1996 to that in 1999?
Offer a very short reply. 1.22. What is the ratio of the ODA received (in %) of Haiti in 1996 to that in 1999?
Your answer should be very brief. 1.97. What is the ratio of the ODA received (in %) in Latin America(all income levels) in 1996 to that in 2000?
Give a very brief answer. 1.79. What is the ratio of the ODA received (in %) in Bahrain in 1996 to that in 2000?
Your response must be concise. 3.74. What is the ratio of the ODA received (in %) of Bangladesh in 1996 to that in 2000?
Your answer should be very brief. 1.38. What is the ratio of the ODA received (in %) in Haiti in 1996 to that in 2000?
Keep it short and to the point. 2.34. What is the ratio of the ODA received (in %) in Latin America(all income levels) in 1996 to that in 2001?
Provide a succinct answer. 1.37. What is the ratio of the ODA received (in %) of Bahrain in 1996 to that in 2001?
Keep it short and to the point. 3. What is the ratio of the ODA received (in %) in Bangladesh in 1996 to that in 2001?
Provide a short and direct response. 1.6. What is the ratio of the ODA received (in %) in Haiti in 1996 to that in 2001?
Make the answer very short. 2.45. What is the ratio of the ODA received (in %) of Latin America(all income levels) in 1996 to that in 2002?
Offer a terse response. 1.4. What is the ratio of the ODA received (in %) in Bahrain in 1996 to that in 2002?
Your answer should be compact. 5.48. What is the ratio of the ODA received (in %) of Bangladesh in 1996 to that in 2002?
Make the answer very short. 1.88. What is the ratio of the ODA received (in %) of Haiti in 1996 to that in 2002?
Your response must be concise. 2.51. What is the ratio of the ODA received (in %) of Latin America(all income levels) in 1996 to that in 2003?
Your response must be concise. 1.2. What is the ratio of the ODA received (in %) of Bahrain in 1996 to that in 2003?
Provide a short and direct response. 3. What is the ratio of the ODA received (in %) of Bangladesh in 1996 to that in 2003?
Provide a short and direct response. 1.36. What is the ratio of the ODA received (in %) in Haiti in 1996 to that in 2003?
Offer a very short reply. 1.92. What is the ratio of the ODA received (in %) of Latin America(all income levels) in 1997 to that in 1998?
Your answer should be very brief. 1.04. What is the ratio of the ODA received (in %) of Bahrain in 1997 to that in 1998?
Your answer should be very brief. 0.9. What is the ratio of the ODA received (in %) of Bangladesh in 1997 to that in 1998?
Make the answer very short. 0.91. What is the ratio of the ODA received (in %) in Haiti in 1997 to that in 1998?
Give a very brief answer. 0.94. What is the ratio of the ODA received (in %) of Latin America(all income levels) in 1997 to that in 1999?
Your answer should be very brief. 0.84. What is the ratio of the ODA received (in %) in Bahrain in 1997 to that in 1999?
Ensure brevity in your answer.  1.15. What is the ratio of the ODA received (in %) in Bangladesh in 1997 to that in 1999?
Offer a terse response. 0.92. What is the ratio of the ODA received (in %) of Haiti in 1997 to that in 1999?
Ensure brevity in your answer.  1.74. What is the ratio of the ODA received (in %) of Latin America(all income levels) in 1997 to that in 2000?
Keep it short and to the point. 1.13. What is the ratio of the ODA received (in %) of Bahrain in 1997 to that in 2000?
Make the answer very short. 3.37. What is the ratio of the ODA received (in %) in Bangladesh in 1997 to that in 2000?
Make the answer very short. 1.04. What is the ratio of the ODA received (in %) of Haiti in 1997 to that in 2000?
Provide a succinct answer. 2.06. What is the ratio of the ODA received (in %) of Latin America(all income levels) in 1997 to that in 2001?
Ensure brevity in your answer.  0.87. What is the ratio of the ODA received (in %) in Bahrain in 1997 to that in 2001?
Provide a short and direct response. 2.7. What is the ratio of the ODA received (in %) of Bangladesh in 1997 to that in 2001?
Make the answer very short. 1.2. What is the ratio of the ODA received (in %) in Haiti in 1997 to that in 2001?
Make the answer very short. 2.17. What is the ratio of the ODA received (in %) of Latin America(all income levels) in 1997 to that in 2002?
Provide a succinct answer. 0.88. What is the ratio of the ODA received (in %) of Bahrain in 1997 to that in 2002?
Offer a very short reply. 4.93. What is the ratio of the ODA received (in %) in Bangladesh in 1997 to that in 2002?
Offer a very short reply. 1.41. What is the ratio of the ODA received (in %) in Haiti in 1997 to that in 2002?
Provide a succinct answer. 2.22. What is the ratio of the ODA received (in %) of Latin America(all income levels) in 1997 to that in 2003?
Provide a succinct answer. 0.76. What is the ratio of the ODA received (in %) in Bahrain in 1997 to that in 2003?
Make the answer very short. 2.71. What is the ratio of the ODA received (in %) of Bangladesh in 1997 to that in 2003?
Offer a very short reply. 1.02. What is the ratio of the ODA received (in %) in Haiti in 1997 to that in 2003?
Offer a terse response. 1.69. What is the ratio of the ODA received (in %) in Latin America(all income levels) in 1998 to that in 1999?
Your answer should be very brief. 0.81. What is the ratio of the ODA received (in %) of Bahrain in 1998 to that in 1999?
Ensure brevity in your answer.  1.28. What is the ratio of the ODA received (in %) in Bangladesh in 1998 to that in 1999?
Ensure brevity in your answer.  1. What is the ratio of the ODA received (in %) in Haiti in 1998 to that in 1999?
Your answer should be very brief. 1.84. What is the ratio of the ODA received (in %) in Latin America(all income levels) in 1998 to that in 2000?
Your answer should be very brief. 1.09. What is the ratio of the ODA received (in %) in Bahrain in 1998 to that in 2000?
Make the answer very short. 3.75. What is the ratio of the ODA received (in %) in Bangladesh in 1998 to that in 2000?
Provide a short and direct response. 1.14. What is the ratio of the ODA received (in %) of Haiti in 1998 to that in 2000?
Ensure brevity in your answer.  2.19. What is the ratio of the ODA received (in %) in Latin America(all income levels) in 1998 to that in 2001?
Your answer should be very brief. 0.84. What is the ratio of the ODA received (in %) of Bahrain in 1998 to that in 2001?
Make the answer very short. 3. What is the ratio of the ODA received (in %) of Bangladesh in 1998 to that in 2001?
Provide a succinct answer. 1.32. What is the ratio of the ODA received (in %) in Haiti in 1998 to that in 2001?
Provide a short and direct response. 2.29. What is the ratio of the ODA received (in %) of Latin America(all income levels) in 1998 to that in 2002?
Provide a succinct answer. 0.85. What is the ratio of the ODA received (in %) of Bahrain in 1998 to that in 2002?
Ensure brevity in your answer.  5.48. What is the ratio of the ODA received (in %) of Bangladesh in 1998 to that in 2002?
Offer a terse response. 1.55. What is the ratio of the ODA received (in %) in Haiti in 1998 to that in 2002?
Your answer should be very brief. 2.35. What is the ratio of the ODA received (in %) of Latin America(all income levels) in 1998 to that in 2003?
Offer a very short reply. 0.73. What is the ratio of the ODA received (in %) of Bahrain in 1998 to that in 2003?
Provide a succinct answer. 3.01. What is the ratio of the ODA received (in %) in Bangladesh in 1998 to that in 2003?
Make the answer very short. 1.12. What is the ratio of the ODA received (in %) of Haiti in 1998 to that in 2003?
Provide a succinct answer. 1.79. What is the ratio of the ODA received (in %) in Latin America(all income levels) in 1999 to that in 2000?
Your answer should be compact. 1.35. What is the ratio of the ODA received (in %) of Bahrain in 1999 to that in 2000?
Offer a very short reply. 2.94. What is the ratio of the ODA received (in %) of Bangladesh in 1999 to that in 2000?
Ensure brevity in your answer.  1.13. What is the ratio of the ODA received (in %) of Haiti in 1999 to that in 2000?
Provide a short and direct response. 1.19. What is the ratio of the ODA received (in %) of Latin America(all income levels) in 1999 to that in 2001?
Make the answer very short. 1.04. What is the ratio of the ODA received (in %) of Bahrain in 1999 to that in 2001?
Offer a very short reply. 2.35. What is the ratio of the ODA received (in %) of Bangladesh in 1999 to that in 2001?
Give a very brief answer. 1.31. What is the ratio of the ODA received (in %) in Haiti in 1999 to that in 2001?
Provide a short and direct response. 1.25. What is the ratio of the ODA received (in %) of Latin America(all income levels) in 1999 to that in 2002?
Ensure brevity in your answer.  1.06. What is the ratio of the ODA received (in %) in Bahrain in 1999 to that in 2002?
Your answer should be very brief. 4.3. What is the ratio of the ODA received (in %) of Bangladesh in 1999 to that in 2002?
Your answer should be compact. 1.54. What is the ratio of the ODA received (in %) of Haiti in 1999 to that in 2002?
Offer a terse response. 1.28. What is the ratio of the ODA received (in %) in Latin America(all income levels) in 1999 to that in 2003?
Keep it short and to the point. 0.91. What is the ratio of the ODA received (in %) in Bahrain in 1999 to that in 2003?
Offer a very short reply. 2.36. What is the ratio of the ODA received (in %) in Bangladesh in 1999 to that in 2003?
Give a very brief answer. 1.11. What is the ratio of the ODA received (in %) of Haiti in 1999 to that in 2003?
Provide a succinct answer. 0.98. What is the ratio of the ODA received (in %) of Latin America(all income levels) in 2000 to that in 2001?
Ensure brevity in your answer.  0.77. What is the ratio of the ODA received (in %) of Bahrain in 2000 to that in 2001?
Give a very brief answer. 0.8. What is the ratio of the ODA received (in %) of Bangladesh in 2000 to that in 2001?
Provide a short and direct response. 1.15. What is the ratio of the ODA received (in %) of Haiti in 2000 to that in 2001?
Ensure brevity in your answer.  1.05. What is the ratio of the ODA received (in %) of Latin America(all income levels) in 2000 to that in 2002?
Give a very brief answer. 0.78. What is the ratio of the ODA received (in %) in Bahrain in 2000 to that in 2002?
Your answer should be very brief. 1.46. What is the ratio of the ODA received (in %) of Bangladesh in 2000 to that in 2002?
Your answer should be very brief. 1.36. What is the ratio of the ODA received (in %) in Haiti in 2000 to that in 2002?
Ensure brevity in your answer.  1.07. What is the ratio of the ODA received (in %) in Latin America(all income levels) in 2000 to that in 2003?
Offer a terse response. 0.67. What is the ratio of the ODA received (in %) in Bahrain in 2000 to that in 2003?
Your answer should be very brief. 0.8. What is the ratio of the ODA received (in %) of Bangladesh in 2000 to that in 2003?
Offer a very short reply. 0.98. What is the ratio of the ODA received (in %) of Haiti in 2000 to that in 2003?
Your answer should be very brief. 0.82. What is the ratio of the ODA received (in %) of Latin America(all income levels) in 2001 to that in 2002?
Ensure brevity in your answer.  1.02. What is the ratio of the ODA received (in %) in Bahrain in 2001 to that in 2002?
Provide a short and direct response. 1.83. What is the ratio of the ODA received (in %) of Bangladesh in 2001 to that in 2002?
Keep it short and to the point. 1.18. What is the ratio of the ODA received (in %) of Haiti in 2001 to that in 2002?
Your answer should be compact. 1.02. What is the ratio of the ODA received (in %) of Latin America(all income levels) in 2001 to that in 2003?
Keep it short and to the point. 0.88. What is the ratio of the ODA received (in %) in Bahrain in 2001 to that in 2003?
Your response must be concise. 1. What is the ratio of the ODA received (in %) in Bangladesh in 2001 to that in 2003?
Keep it short and to the point. 0.85. What is the ratio of the ODA received (in %) of Haiti in 2001 to that in 2003?
Ensure brevity in your answer.  0.78. What is the ratio of the ODA received (in %) in Latin America(all income levels) in 2002 to that in 2003?
Your answer should be compact. 0.86. What is the ratio of the ODA received (in %) in Bahrain in 2002 to that in 2003?
Give a very brief answer. 0.55. What is the ratio of the ODA received (in %) of Bangladesh in 2002 to that in 2003?
Give a very brief answer. 0.72. What is the ratio of the ODA received (in %) in Haiti in 2002 to that in 2003?
Provide a short and direct response. 0.76. What is the difference between the highest and the second highest ODA received (in %) in Latin America(all income levels)?
Make the answer very short. 0.33. What is the difference between the highest and the second highest ODA received (in %) in Bahrain?
Provide a short and direct response. 0.02. What is the difference between the highest and the second highest ODA received (in %) of Bangladesh?
Make the answer very short. 2.24. What is the difference between the highest and the second highest ODA received (in %) in Haiti?
Keep it short and to the point. 2.88. What is the difference between the highest and the lowest ODA received (in %) of Latin America(all income levels)?
Offer a terse response. 0.85. What is the difference between the highest and the lowest ODA received (in %) in Bahrain?
Offer a terse response. 12.33. What is the difference between the highest and the lowest ODA received (in %) of Bangladesh?
Provide a succinct answer. 5.95. What is the difference between the highest and the lowest ODA received (in %) of Haiti?
Give a very brief answer. 27.01. 